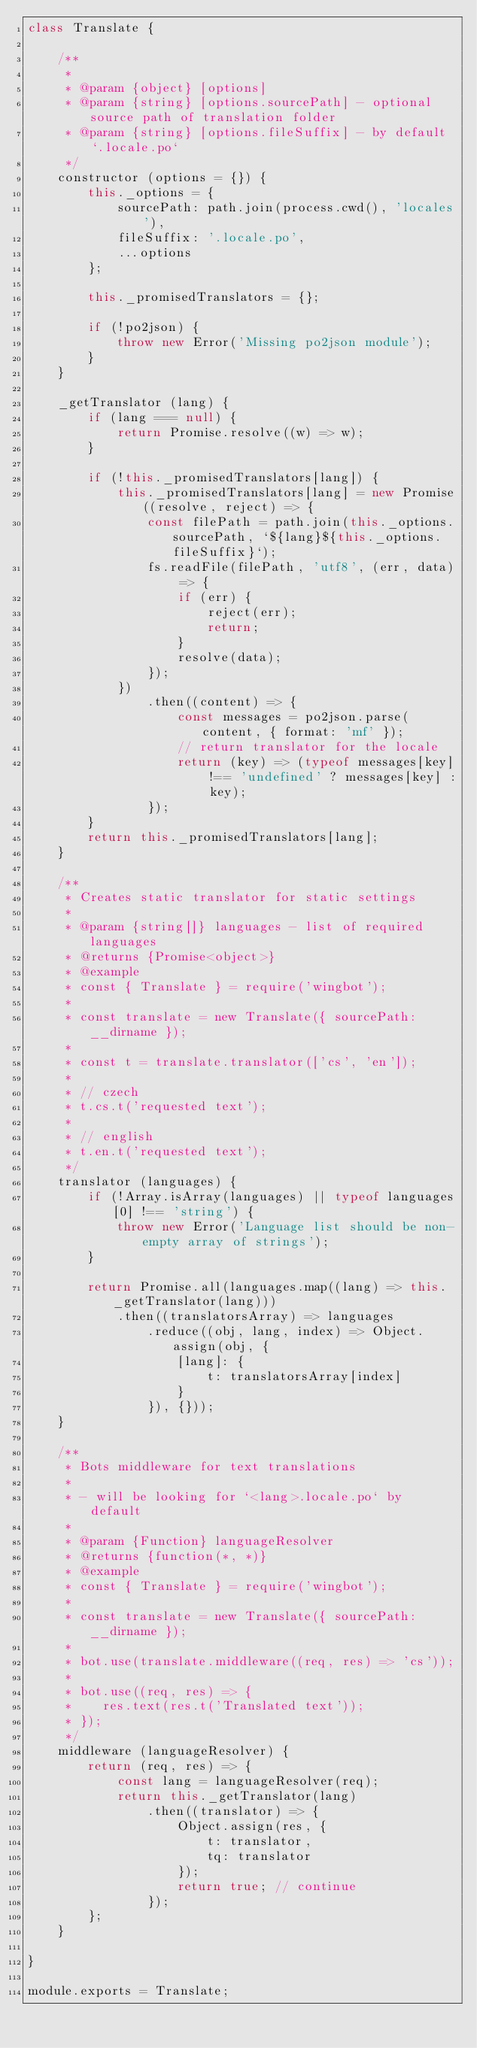Convert code to text. <code><loc_0><loc_0><loc_500><loc_500><_JavaScript_>class Translate {

    /**
     *
     * @param {object} [options]
     * @param {string} [options.sourcePath] - optional source path of translation folder
     * @param {string} [options.fileSuffix] - by default `.locale.po`
     */
    constructor (options = {}) {
        this._options = {
            sourcePath: path.join(process.cwd(), 'locales'),
            fileSuffix: '.locale.po',
            ...options
        };

        this._promisedTranslators = {};

        if (!po2json) {
            throw new Error('Missing po2json module');
        }
    }

    _getTranslator (lang) {
        if (lang === null) {
            return Promise.resolve((w) => w);
        }

        if (!this._promisedTranslators[lang]) {
            this._promisedTranslators[lang] = new Promise((resolve, reject) => {
                const filePath = path.join(this._options.sourcePath, `${lang}${this._options.fileSuffix}`);
                fs.readFile(filePath, 'utf8', (err, data) => {
                    if (err) {
                        reject(err);
                        return;
                    }
                    resolve(data);
                });
            })
                .then((content) => {
                    const messages = po2json.parse(content, { format: 'mf' });
                    // return translator for the locale
                    return (key) => (typeof messages[key] !== 'undefined' ? messages[key] : key);
                });
        }
        return this._promisedTranslators[lang];
    }

    /**
     * Creates static translator for static settings
     *
     * @param {string[]} languages - list of required languages
     * @returns {Promise<object>}
     * @example
     * const { Translate } = require('wingbot');
     *
     * const translate = new Translate({ sourcePath: __dirname });
     *
     * const t = translate.translator(['cs', 'en']);
     *
     * // czech
     * t.cs.t('requested text');
     *
     * // english
     * t.en.t('requested text');
     */
    translator (languages) {
        if (!Array.isArray(languages) || typeof languages[0] !== 'string') {
            throw new Error('Language list should be non-empty array of strings');
        }

        return Promise.all(languages.map((lang) => this._getTranslator(lang)))
            .then((translatorsArray) => languages
                .reduce((obj, lang, index) => Object.assign(obj, {
                    [lang]: {
                        t: translatorsArray[index]
                    }
                }), {}));
    }

    /**
     * Bots middleware for text translations
     *
     * - will be looking for `<lang>.locale.po` by default
     *
     * @param {Function} languageResolver
     * @returns {function(*, *)}
     * @example
     * const { Translate } = require('wingbot');
     *
     * const translate = new Translate({ sourcePath: __dirname });
     *
     * bot.use(translate.middleware((req, res) => 'cs'));
     *
     * bot.use((req, res) => {
     *    res.text(res.t('Translated text'));
     * });
     */
    middleware (languageResolver) {
        return (req, res) => {
            const lang = languageResolver(req);
            return this._getTranslator(lang)
                .then((translator) => {
                    Object.assign(res, {
                        t: translator,
                        tq: translator
                    });
                    return true; // continue
                });
        };
    }

}

module.exports = Translate;
</code> 